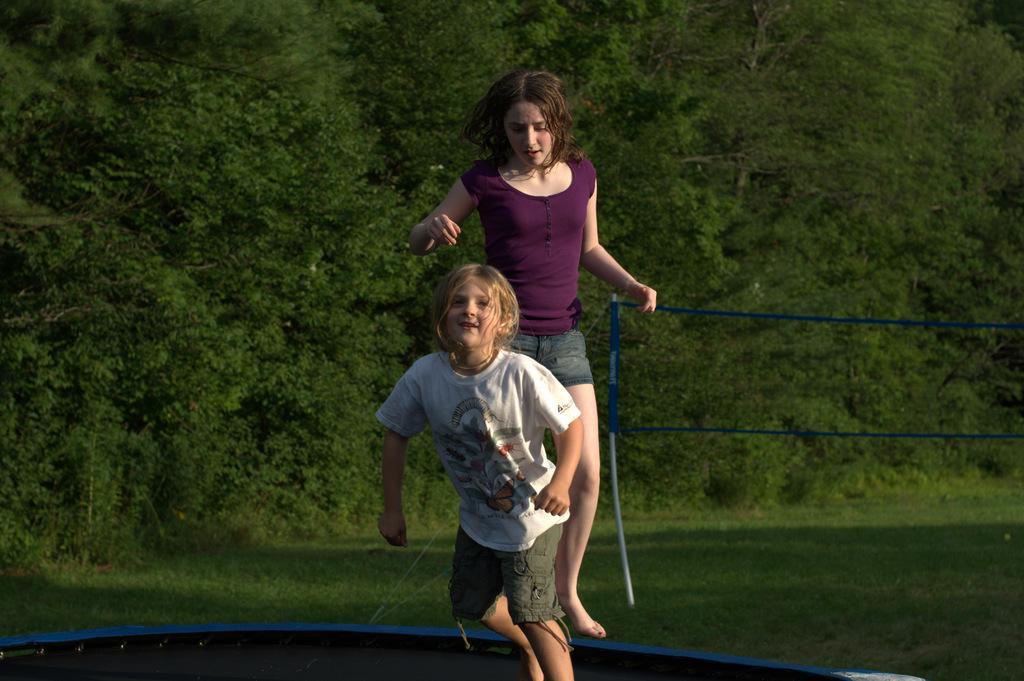In one or two sentences, can you explain what this image depicts? The picture seems to be clicked outside. In the foreground we can see a kid wearing white color t-shirt and seems to be running on a black color object and we can see a woman wearing t-shirt and seems to be running. On the right we can see the net and a rod and we can see the green grass, plants and trees. 